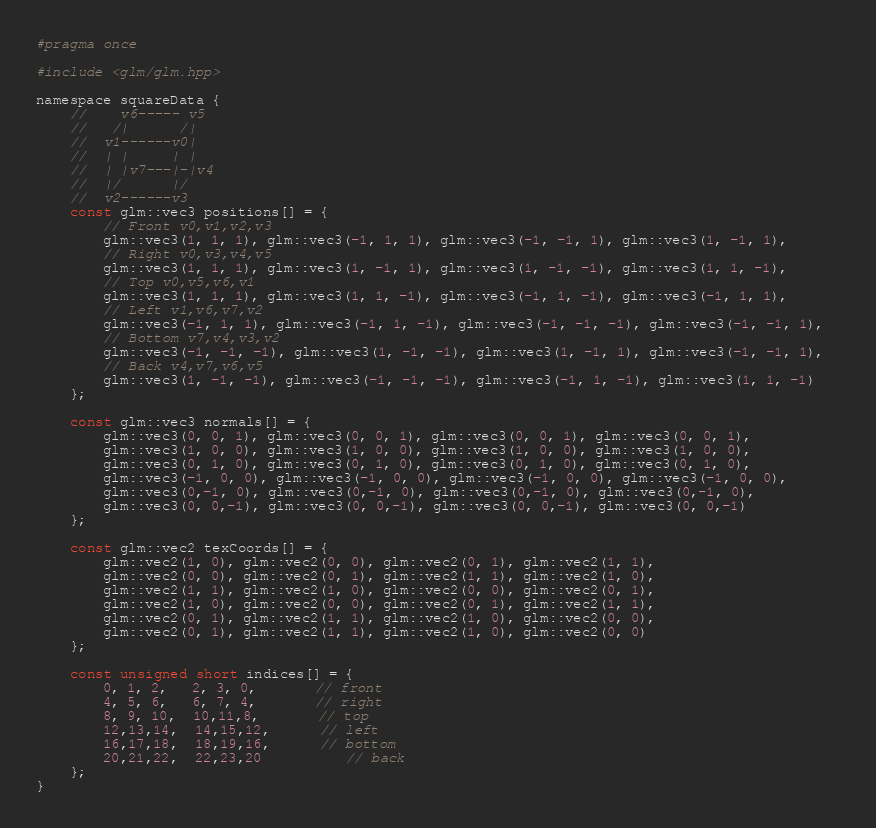<code> <loc_0><loc_0><loc_500><loc_500><_C_>#pragma once

#include <glm/glm.hpp>

namespace squareData {
    //    v6----- v5
    //   /|      /|
    //  v1------v0|
    //  | |     | |
    //  | |v7---|-|v4
    //  |/      |/
    //  v2------v3
    const glm::vec3 positions[] = {
        // Front v0,v1,v2,v3
        glm::vec3(1, 1, 1), glm::vec3(-1, 1, 1), glm::vec3(-1, -1, 1), glm::vec3(1, -1, 1),
        // Right v0,v3,v4,v5
        glm::vec3(1, 1, 1), glm::vec3(1, -1, 1), glm::vec3(1, -1, -1), glm::vec3(1, 1, -1),
        // Top v0,v5,v6,v1	
        glm::vec3(1, 1, 1), glm::vec3(1, 1, -1), glm::vec3(-1, 1, -1), glm::vec3(-1, 1, 1), 
        // Left v1,v6,v7,v2	
        glm::vec3(-1, 1, 1), glm::vec3(-1, 1, -1), glm::vec3(-1, -1, -1), glm::vec3(-1, -1, 1),  
        // Bottom v7,v4,v3,v2
        glm::vec3(-1, -1, -1), glm::vec3(1, -1, -1), glm::vec3(1, -1, 1), glm::vec3(-1, -1, 1), 
        // Back v4,v7,v6,v5	
        glm::vec3(1, -1, -1), glm::vec3(-1, -1, -1), glm::vec3(-1, 1, -1), glm::vec3(1, 1, -1)
    };

    const glm::vec3 normals[] = {
        glm::vec3(0, 0, 1), glm::vec3(0, 0, 1), glm::vec3(0, 0, 1), glm::vec3(0, 0, 1),
        glm::vec3(1, 0, 0), glm::vec3(1, 0, 0), glm::vec3(1, 0, 0), glm::vec3(1, 0, 0),
        glm::vec3(0, 1, 0), glm::vec3(0, 1, 0), glm::vec3(0, 1, 0), glm::vec3(0, 1, 0),
        glm::vec3(-1, 0, 0), glm::vec3(-1, 0, 0), glm::vec3(-1, 0, 0), glm::vec3(-1, 0, 0),
        glm::vec3(0,-1, 0), glm::vec3(0,-1, 0), glm::vec3(0,-1, 0), glm::vec3(0,-1, 0),
        glm::vec3(0, 0,-1), glm::vec3(0, 0,-1), glm::vec3(0, 0,-1), glm::vec3(0, 0,-1)
    };

    const glm::vec2 texCoords[] = {
        glm::vec2(1, 0), glm::vec2(0, 0), glm::vec2(0, 1), glm::vec2(1, 1),
        glm::vec2(0, 0), glm::vec2(0, 1), glm::vec2(1, 1), glm::vec2(1, 0),
        glm::vec2(1, 1), glm::vec2(1, 0), glm::vec2(0, 0), glm::vec2(0, 1),
        glm::vec2(1, 0), glm::vec2(0, 0), glm::vec2(0, 1), glm::vec2(1, 1),
        glm::vec2(0, 1), glm::vec2(1, 1), glm::vec2(1, 0), glm::vec2(0, 0),
        glm::vec2(0, 1), glm::vec2(1, 1), glm::vec2(1, 0), glm::vec2(0, 0)
    };

    const unsigned short indices[] = {
        0, 1, 2,   2, 3, 0,       // front
        4, 5, 6,   6, 7, 4,       // right
        8, 9, 10,  10,11,8,       // top
        12,13,14,  14,15,12,      // left
        16,17,18,  18,19,16,      // bottom
        20,21,22,  22,23,20		  // back
    };
}
</code> 